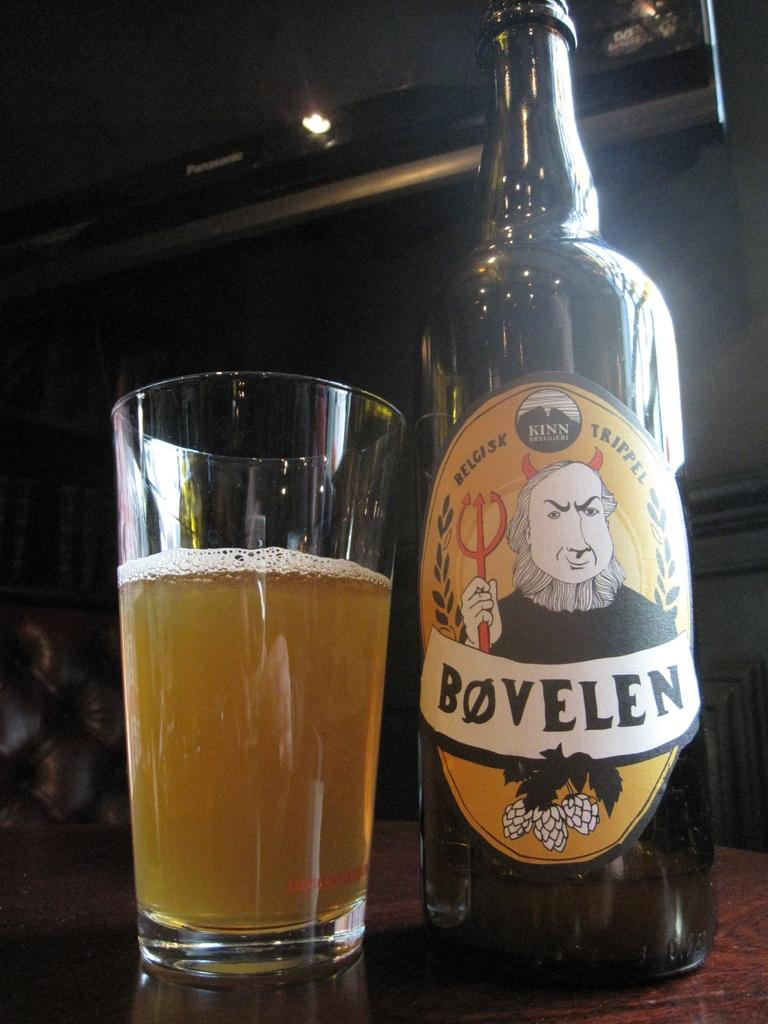What is the name of this beer?
Provide a short and direct response. Bovelen. What is the brand of this beer?
Your answer should be compact. Bovelen. 